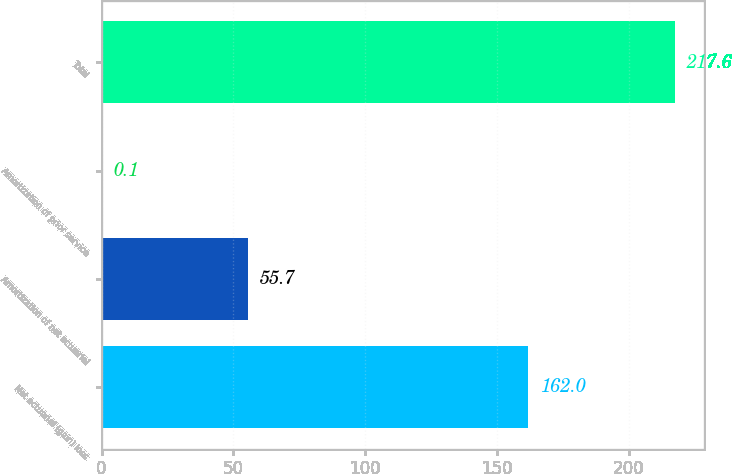<chart> <loc_0><loc_0><loc_500><loc_500><bar_chart><fcel>Net actuarial (gain) loss<fcel>Amortization of net actuarial<fcel>Amortization of prior service<fcel>Total<nl><fcel>162<fcel>55.7<fcel>0.1<fcel>217.6<nl></chart> 